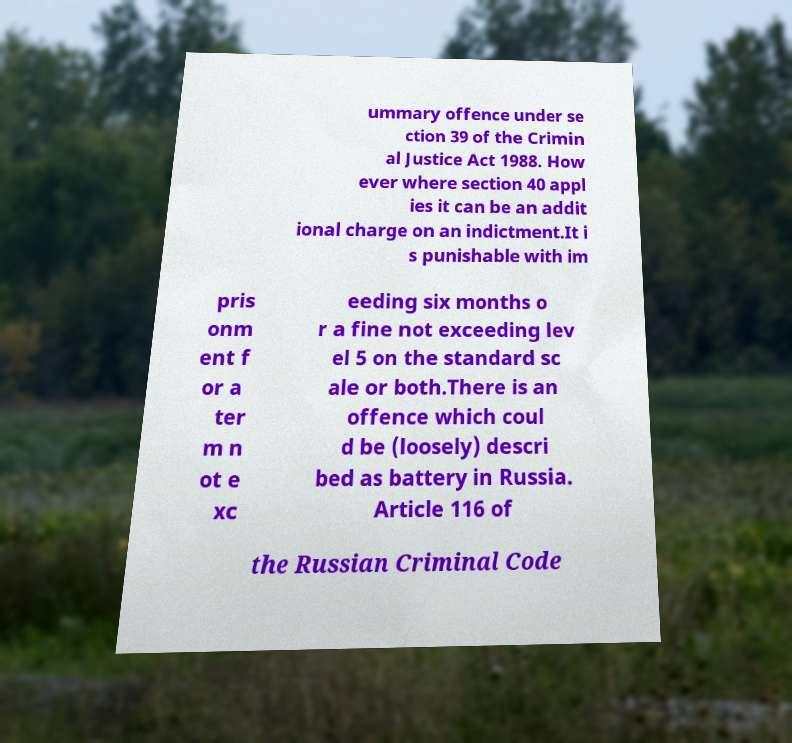Please read and relay the text visible in this image. What does it say? ummary offence under se ction 39 of the Crimin al Justice Act 1988. How ever where section 40 appl ies it can be an addit ional charge on an indictment.It i s punishable with im pris onm ent f or a ter m n ot e xc eeding six months o r a fine not exceeding lev el 5 on the standard sc ale or both.There is an offence which coul d be (loosely) descri bed as battery in Russia. Article 116 of the Russian Criminal Code 